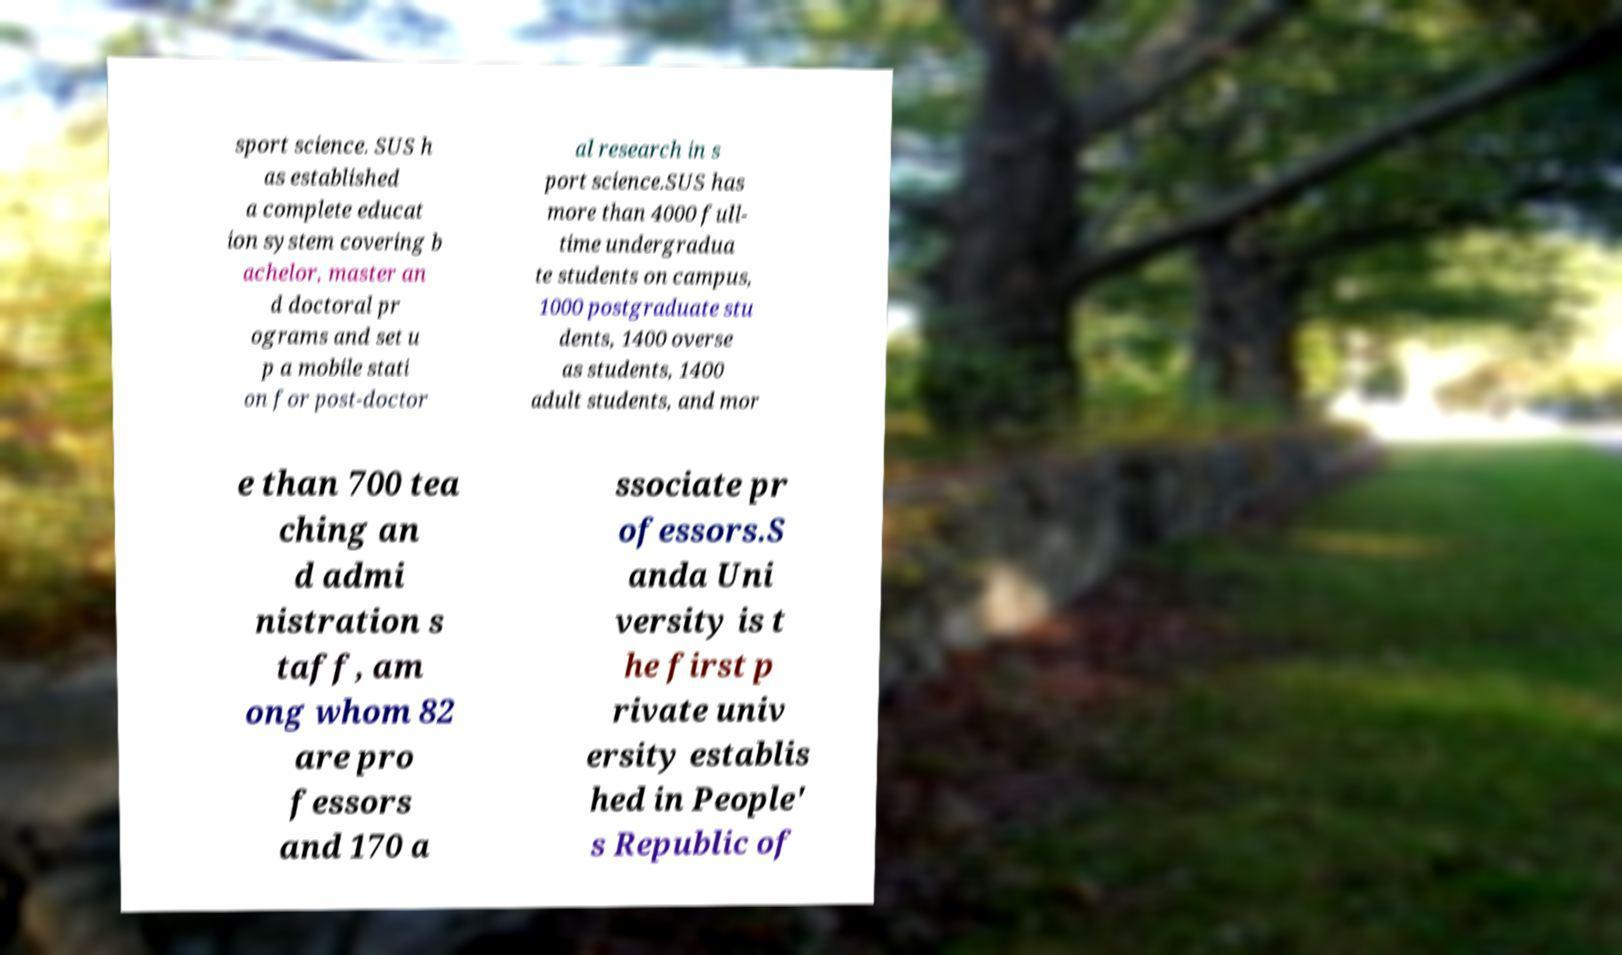I need the written content from this picture converted into text. Can you do that? sport science. SUS h as established a complete educat ion system covering b achelor, master an d doctoral pr ograms and set u p a mobile stati on for post-doctor al research in s port science.SUS has more than 4000 full- time undergradua te students on campus, 1000 postgraduate stu dents, 1400 overse as students, 1400 adult students, and mor e than 700 tea ching an d admi nistration s taff, am ong whom 82 are pro fessors and 170 a ssociate pr ofessors.S anda Uni versity is t he first p rivate univ ersity establis hed in People' s Republic of 